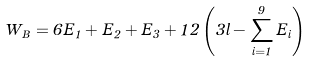<formula> <loc_0><loc_0><loc_500><loc_500>W _ { B } = 6 E _ { 1 } + E _ { 2 } + E _ { 3 } + 1 2 \left ( 3 l - \sum _ { i = 1 } ^ { 9 } E _ { i } \right )</formula> 